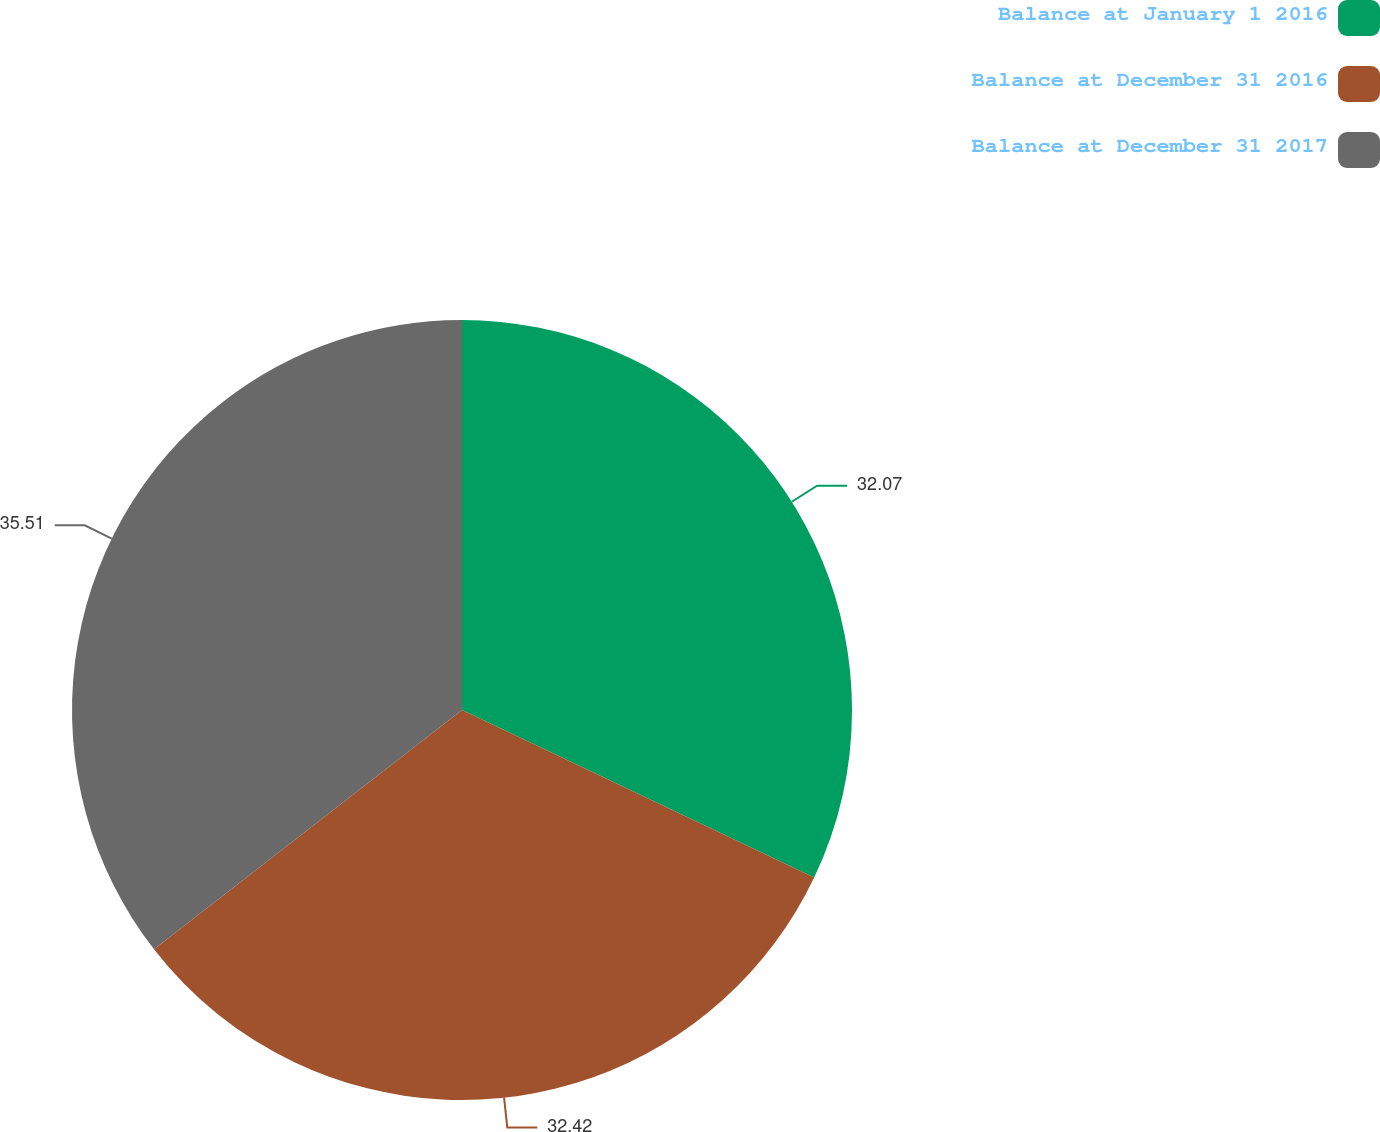Convert chart to OTSL. <chart><loc_0><loc_0><loc_500><loc_500><pie_chart><fcel>Balance at January 1 2016<fcel>Balance at December 31 2016<fcel>Balance at December 31 2017<nl><fcel>32.07%<fcel>32.42%<fcel>35.51%<nl></chart> 